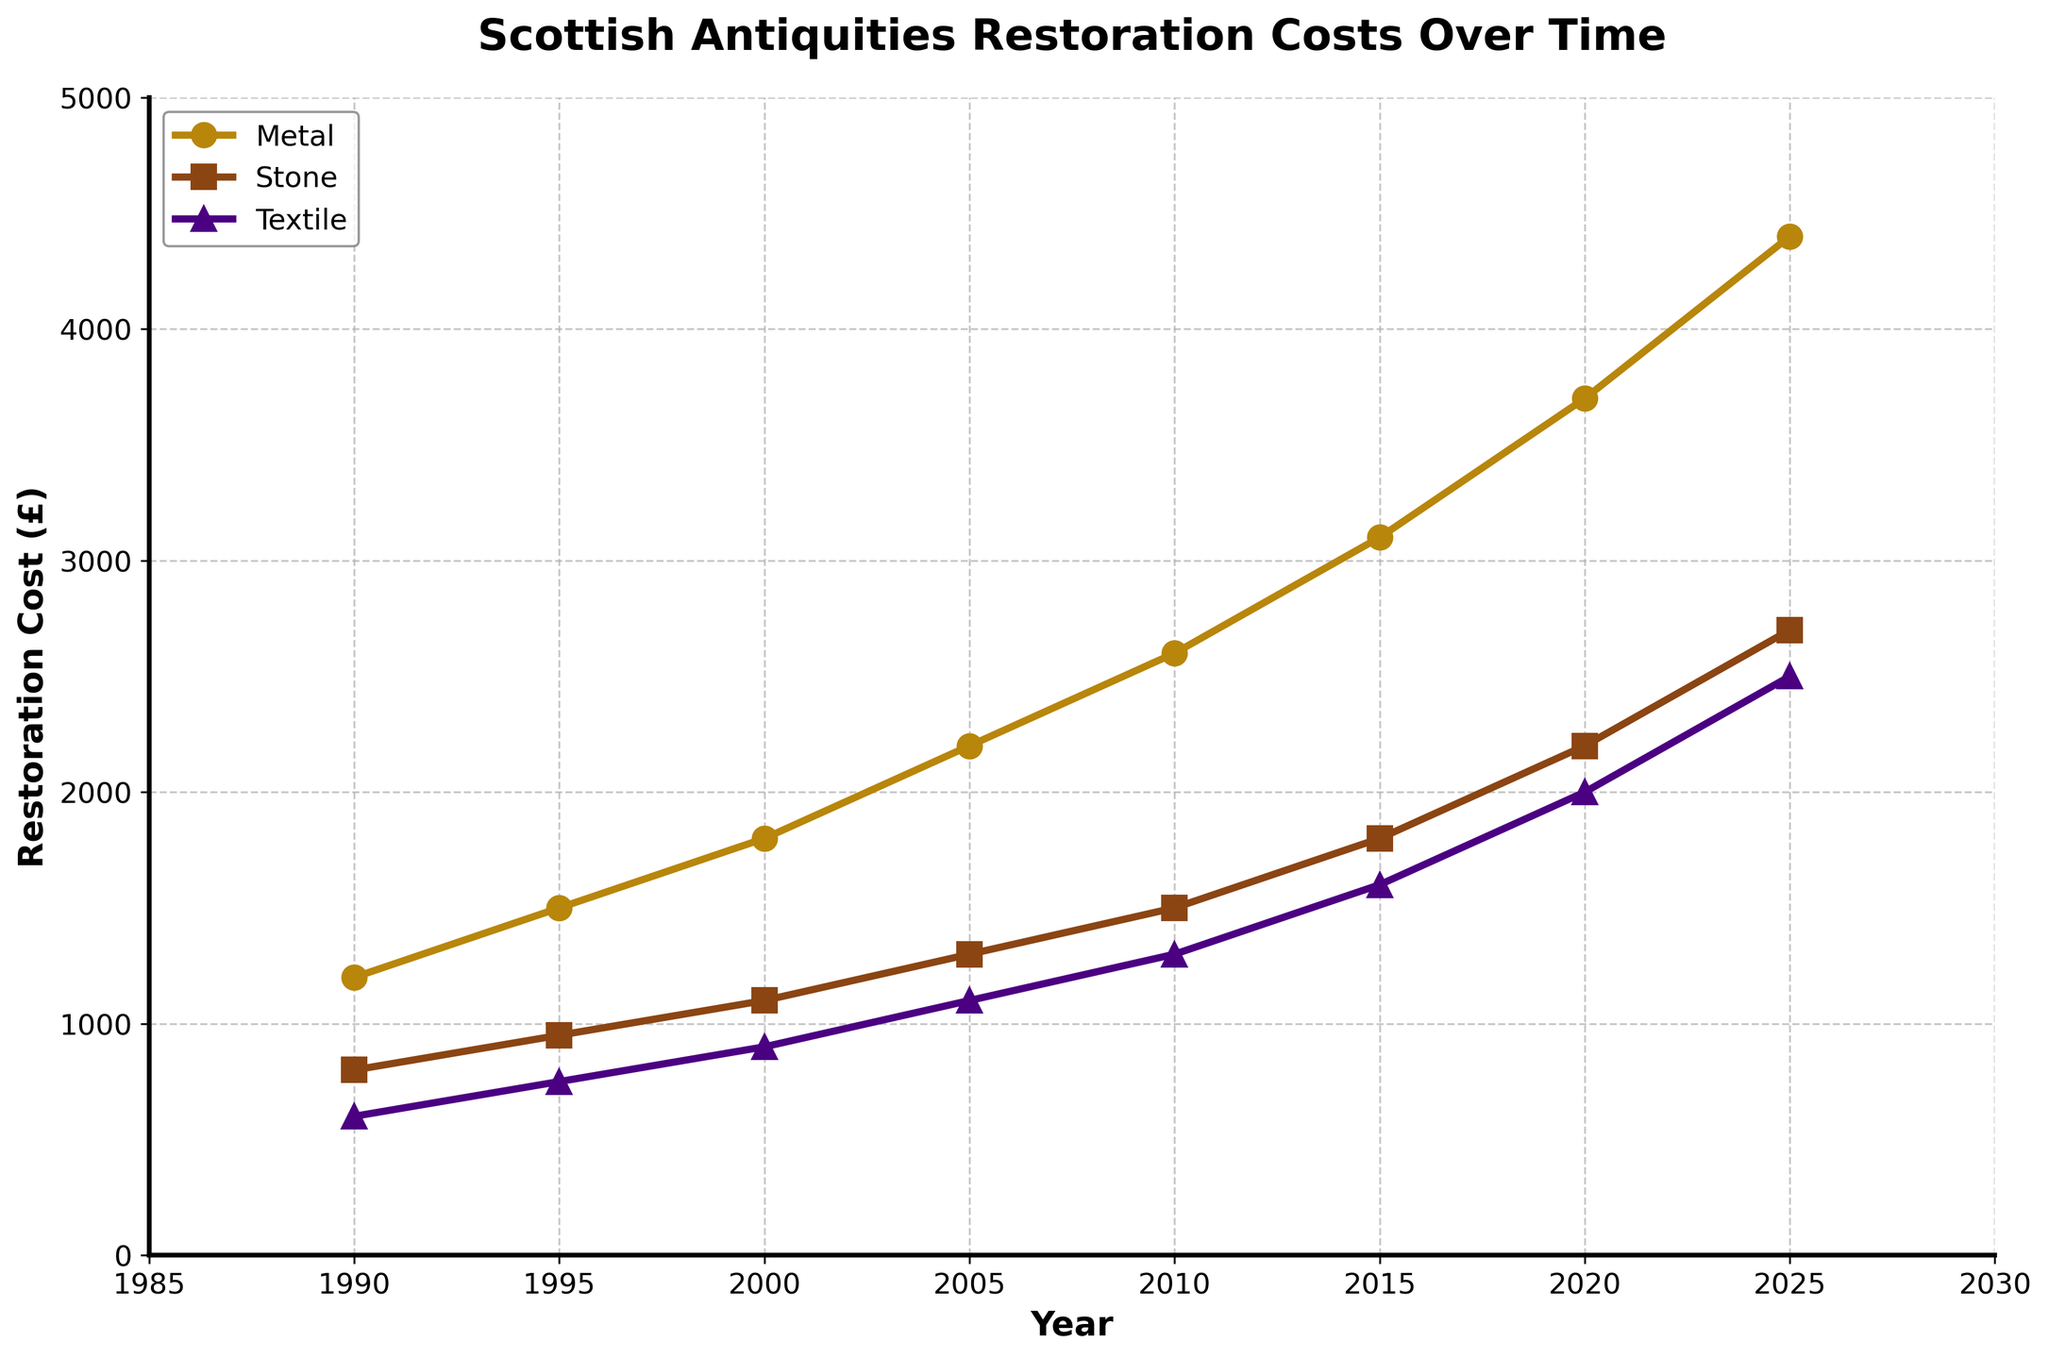What is the overall trend in restoration costs for metallic artifacts from 1990 to 2025? The line for Metal shows an upward trend from 1990 to 2025. The costs increase steadily from £1200 in 1990 to £4400 in 2025.
Answer: Upward trend Which material had the highest restoration cost in 2020? By comparing the height of the lines above the year 2020, the Metal line is the tallest, indicating the highest cost at £3700.
Answer: Metal How did the restoration cost for stone artifacts change between 2005 and 2010? The cost increased from £1300 in 2005 to £1500 in 2010, showing a rise of £200.
Answer: Increased by £200 Which material showed the least increase in restoration costs from 1990 to 2025? Comparing the increases for each material (Metal: £3200, Stone: £1900, Textile: £1900), both Stone and Textile have the least increase in costs.
Answer: Stone and Textile What was the difference in restoration costs between metal and textile artifacts in 2015? The cost for Metal was £3100 and for Textile was £1600 in 2015. The difference is £3100 - £1600 = £1500.
Answer: £1500 In which year did the restoration cost of textile artifacts first exceed £2000? Looking at the Textile line, it crosses £2000 around 2020 with a cost of £2000.
Answer: 2020 By how much did the restoration cost for stone artifacts increase from 1995 to 2020? From the figure, the cost for Stone in 1995 was £950 and in 2020 was £2200. The increase is £2200 - £950 = £1250.
Answer: £1250 What was the cost difference between metal and stone artifacts in 2000? The cost for Metal was £1800 and for Stone was £1100 in 2000. The difference is £1800 - £1100 = £700.
Answer: £700 What is the average restoration cost for textile artifacts over the given years? Sum the costs for Textile (600 + 750 + 900 + 1100 + 1300 + 1600 + 2000 + 2500 = 10750), then divide by the number of years (8), the average is 10750 / 8 = 1343.75.
Answer: £1343.75 Between which consecutive years did the restoration cost for metal artifacts increase the most? The largest increase occurs between 2015 and 2020 (from £3100 to £3700), an increase of £600.
Answer: 2015 to 2020 